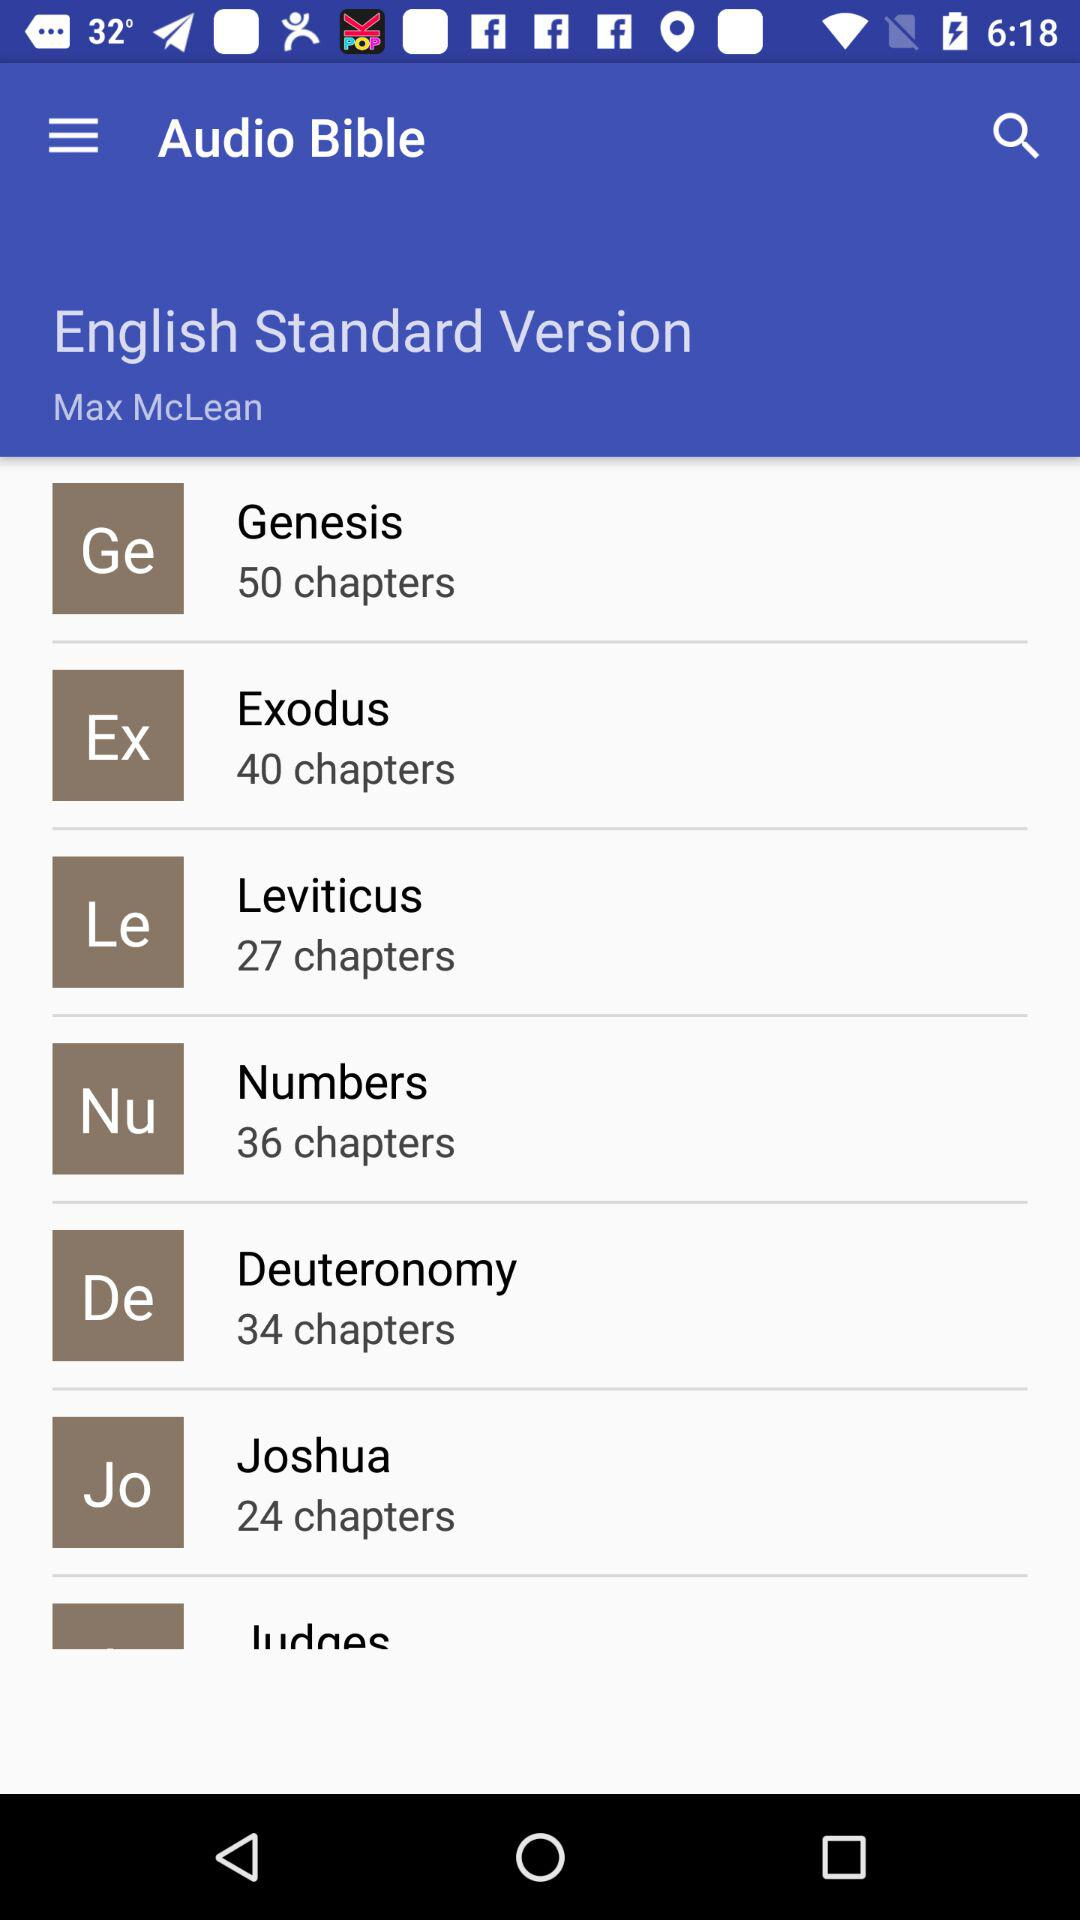How many chapters are there in Exodus? There are 50 chapters. 